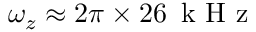Convert formula to latex. <formula><loc_0><loc_0><loc_500><loc_500>\omega _ { z } \approx 2 \pi \times 2 6 \, k H z</formula> 